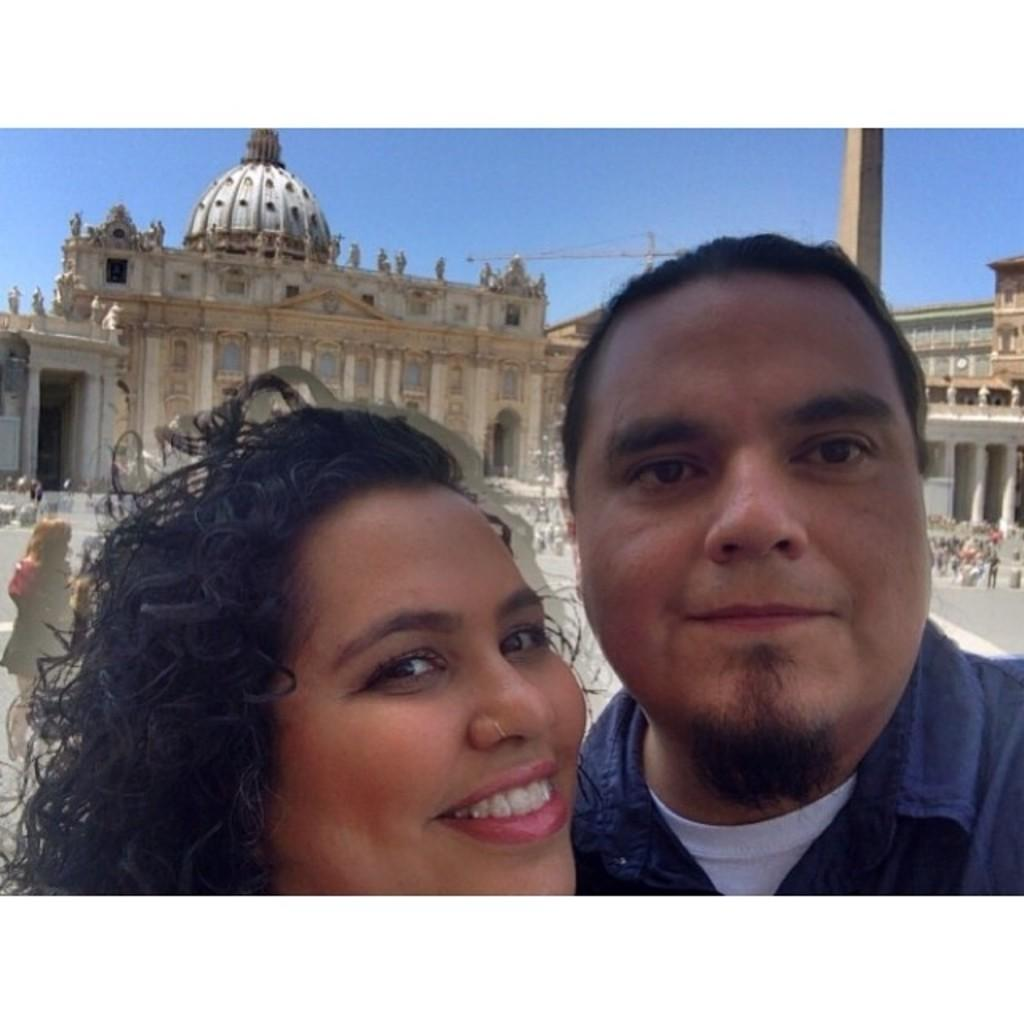How many people are standing and smiling in the image? There are two persons standing and smiling in the image. Are there any other people present in the image? Yes, there are other people standing behind them. What type of structures can be seen in the image? There are buildings visible in the image. What is visible at the top of the image? The sky is visible at the top of the image. What type of cent is visible in the image? There is no cent present in the image. Is there any steam coming from the people in the image? There is no steam visible in the image. 